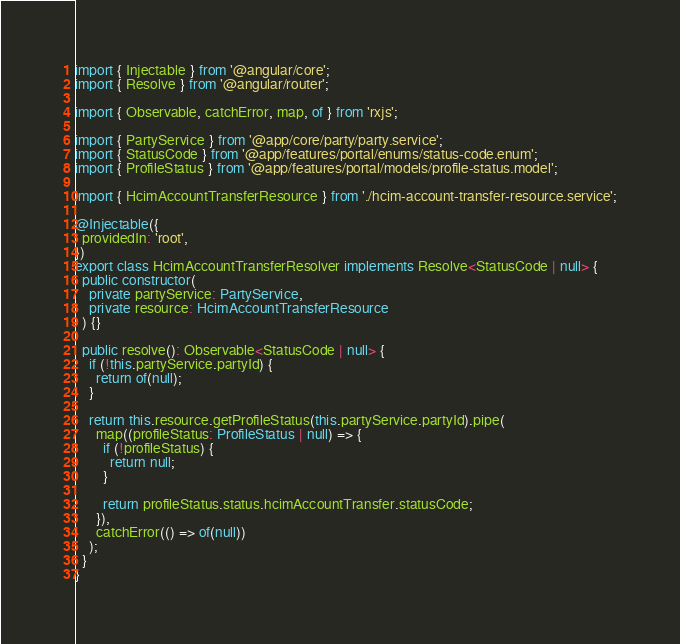Convert code to text. <code><loc_0><loc_0><loc_500><loc_500><_TypeScript_>import { Injectable } from '@angular/core';
import { Resolve } from '@angular/router';

import { Observable, catchError, map, of } from 'rxjs';

import { PartyService } from '@app/core/party/party.service';
import { StatusCode } from '@app/features/portal/enums/status-code.enum';
import { ProfileStatus } from '@app/features/portal/models/profile-status.model';

import { HcimAccountTransferResource } from './hcim-account-transfer-resource.service';

@Injectable({
  providedIn: 'root',
})
export class HcimAccountTransferResolver implements Resolve<StatusCode | null> {
  public constructor(
    private partyService: PartyService,
    private resource: HcimAccountTransferResource
  ) {}

  public resolve(): Observable<StatusCode | null> {
    if (!this.partyService.partyId) {
      return of(null);
    }

    return this.resource.getProfileStatus(this.partyService.partyId).pipe(
      map((profileStatus: ProfileStatus | null) => {
        if (!profileStatus) {
          return null;
        }

        return profileStatus.status.hcimAccountTransfer.statusCode;
      }),
      catchError(() => of(null))
    );
  }
}
</code> 